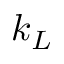<formula> <loc_0><loc_0><loc_500><loc_500>k _ { L }</formula> 